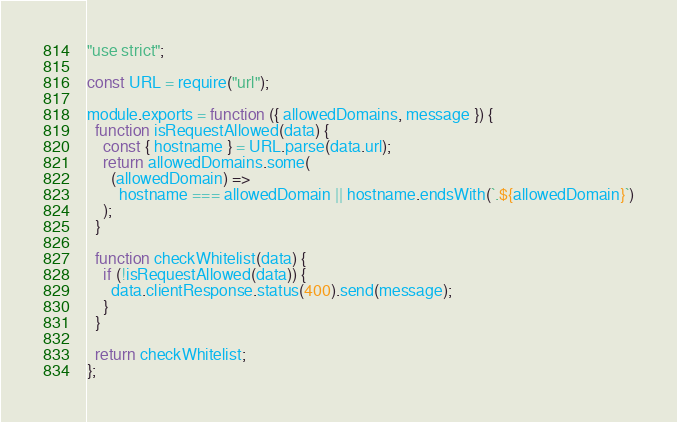<code> <loc_0><loc_0><loc_500><loc_500><_JavaScript_>"use strict";

const URL = require("url");

module.exports = function ({ allowedDomains, message }) {
  function isRequestAllowed(data) {
    const { hostname } = URL.parse(data.url);
    return allowedDomains.some(
      (allowedDomain) =>
        hostname === allowedDomain || hostname.endsWith(`.${allowedDomain}`)
    );
  }

  function checkWhitelist(data) {
    if (!isRequestAllowed(data)) {
      data.clientResponse.status(400).send(message);
    }
  }

  return checkWhitelist;
};
</code> 